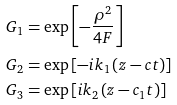Convert formula to latex. <formula><loc_0><loc_0><loc_500><loc_500>G _ { 1 } & = \exp \left [ - \frac { \rho ^ { 2 } } { 4 F } \right ] \\ G _ { 2 } & = \exp \left [ - i k _ { 1 } \left ( z - c t \right ) \right ] \\ G _ { 3 } & = \exp \left [ i k _ { 2 } \left ( z - c _ { 1 } t \right ) \right ]</formula> 